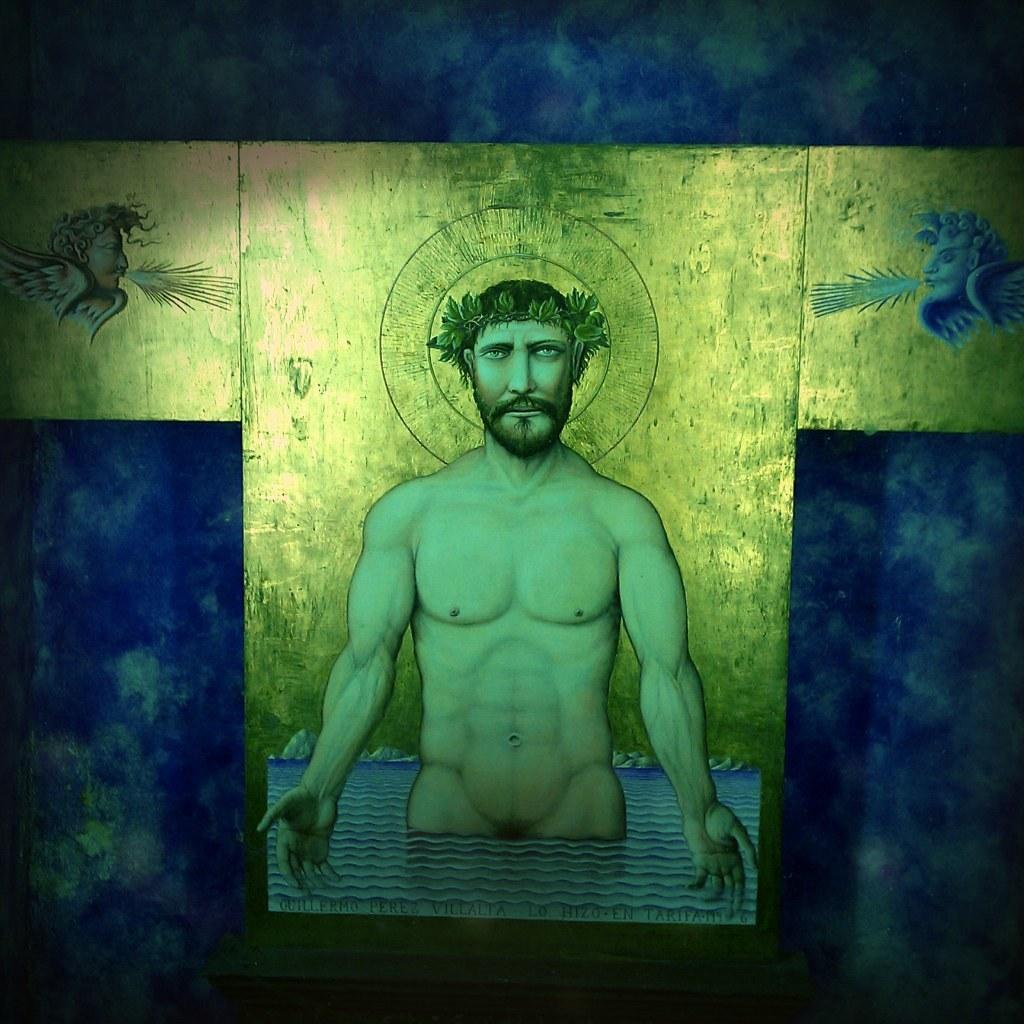Could you give a brief overview of what you see in this image? In the image we can see a picture of a person standing in the water and this is a leaf crown. This is a water, painting and a golden sheet. We can see there are even two more people with feathers. 